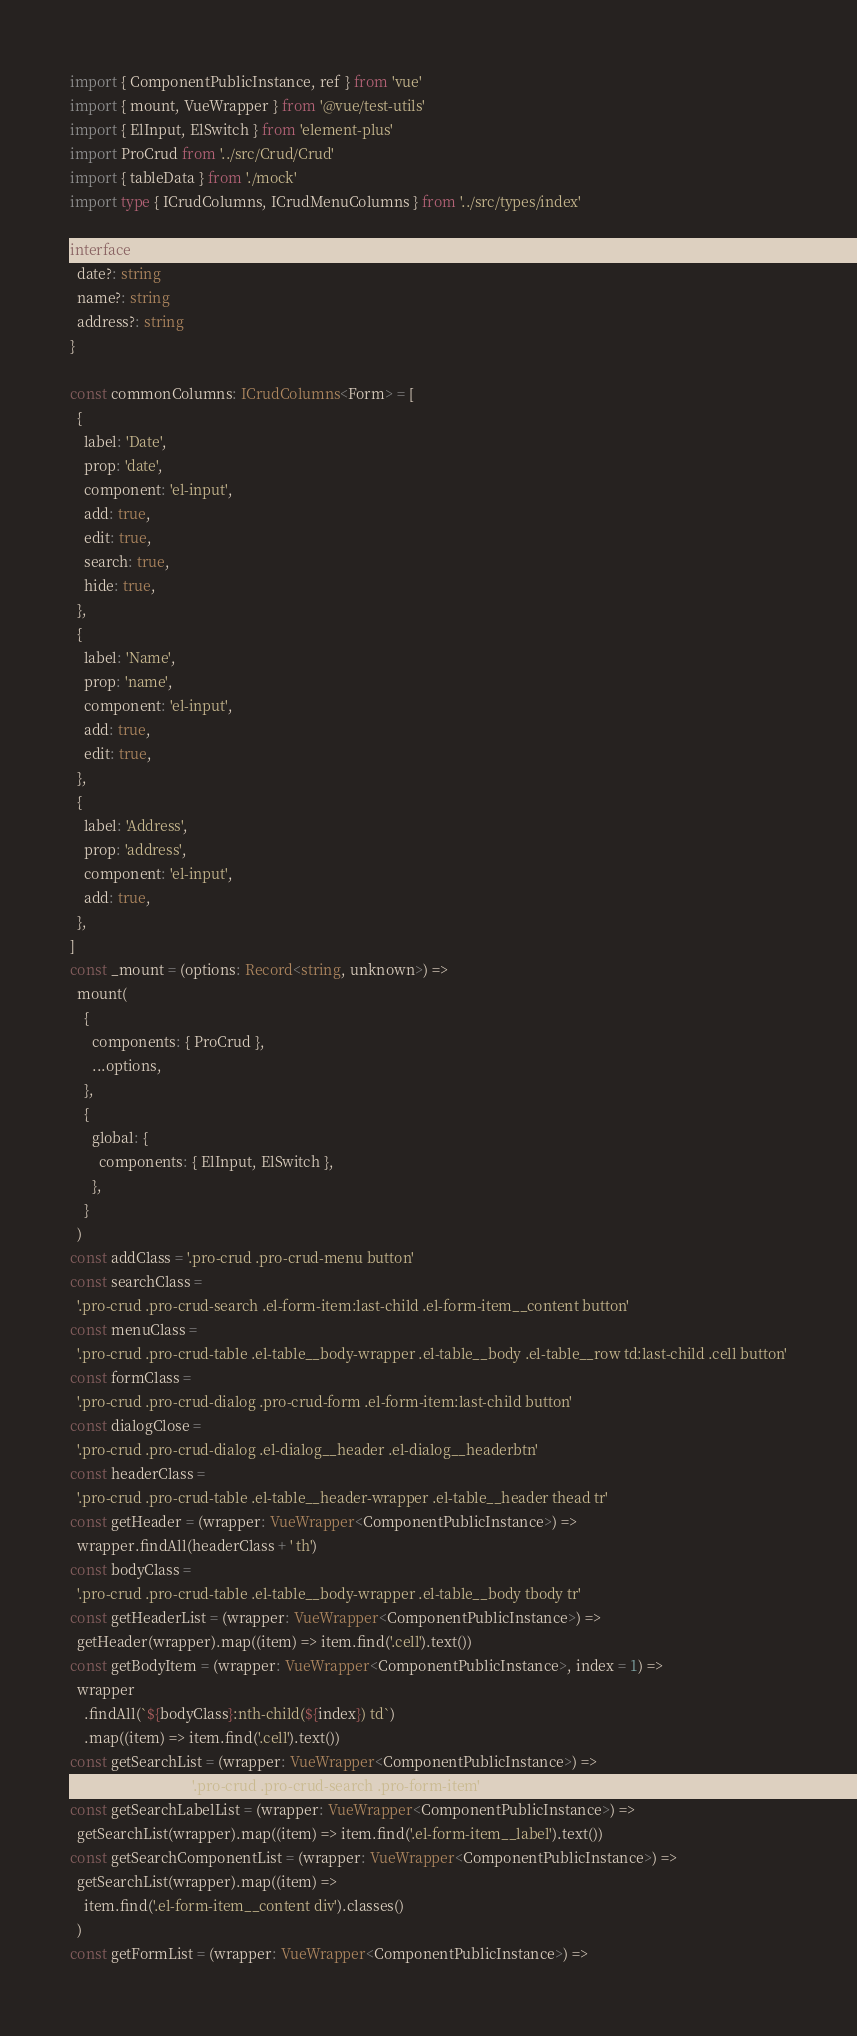<code> <loc_0><loc_0><loc_500><loc_500><_TypeScript_>import { ComponentPublicInstance, ref } from 'vue'
import { mount, VueWrapper } from '@vue/test-utils'
import { ElInput, ElSwitch } from 'element-plus'
import ProCrud from '../src/Crud/Crud'
import { tableData } from './mock'
import type { ICrudColumns, ICrudMenuColumns } from '../src/types/index'

interface Form {
  date?: string
  name?: string
  address?: string
}

const commonColumns: ICrudColumns<Form> = [
  {
    label: 'Date',
    prop: 'date',
    component: 'el-input',
    add: true,
    edit: true,
    search: true,
    hide: true,
  },
  {
    label: 'Name',
    prop: 'name',
    component: 'el-input',
    add: true,
    edit: true,
  },
  {
    label: 'Address',
    prop: 'address',
    component: 'el-input',
    add: true,
  },
]
const _mount = (options: Record<string, unknown>) =>
  mount(
    {
      components: { ProCrud },
      ...options,
    },
    {
      global: {
        components: { ElInput, ElSwitch },
      },
    }
  )
const addClass = '.pro-crud .pro-crud-menu button'
const searchClass =
  '.pro-crud .pro-crud-search .el-form-item:last-child .el-form-item__content button'
const menuClass =
  '.pro-crud .pro-crud-table .el-table__body-wrapper .el-table__body .el-table__row td:last-child .cell button'
const formClass =
  '.pro-crud .pro-crud-dialog .pro-crud-form .el-form-item:last-child button'
const dialogClose =
  '.pro-crud .pro-crud-dialog .el-dialog__header .el-dialog__headerbtn'
const headerClass =
  '.pro-crud .pro-crud-table .el-table__header-wrapper .el-table__header thead tr'
const getHeader = (wrapper: VueWrapper<ComponentPublicInstance>) =>
  wrapper.findAll(headerClass + ' th')
const bodyClass =
  '.pro-crud .pro-crud-table .el-table__body-wrapper .el-table__body tbody tr'
const getHeaderList = (wrapper: VueWrapper<ComponentPublicInstance>) =>
  getHeader(wrapper).map((item) => item.find('.cell').text())
const getBodyItem = (wrapper: VueWrapper<ComponentPublicInstance>, index = 1) =>
  wrapper
    .findAll(`${bodyClass}:nth-child(${index}) td`)
    .map((item) => item.find('.cell').text())
const getSearchList = (wrapper: VueWrapper<ComponentPublicInstance>) =>
  wrapper.findAll('.pro-crud .pro-crud-search .pro-form-item')
const getSearchLabelList = (wrapper: VueWrapper<ComponentPublicInstance>) =>
  getSearchList(wrapper).map((item) => item.find('.el-form-item__label').text())
const getSearchComponentList = (wrapper: VueWrapper<ComponentPublicInstance>) =>
  getSearchList(wrapper).map((item) =>
    item.find('.el-form-item__content div').classes()
  )
const getFormList = (wrapper: VueWrapper<ComponentPublicInstance>) =></code> 